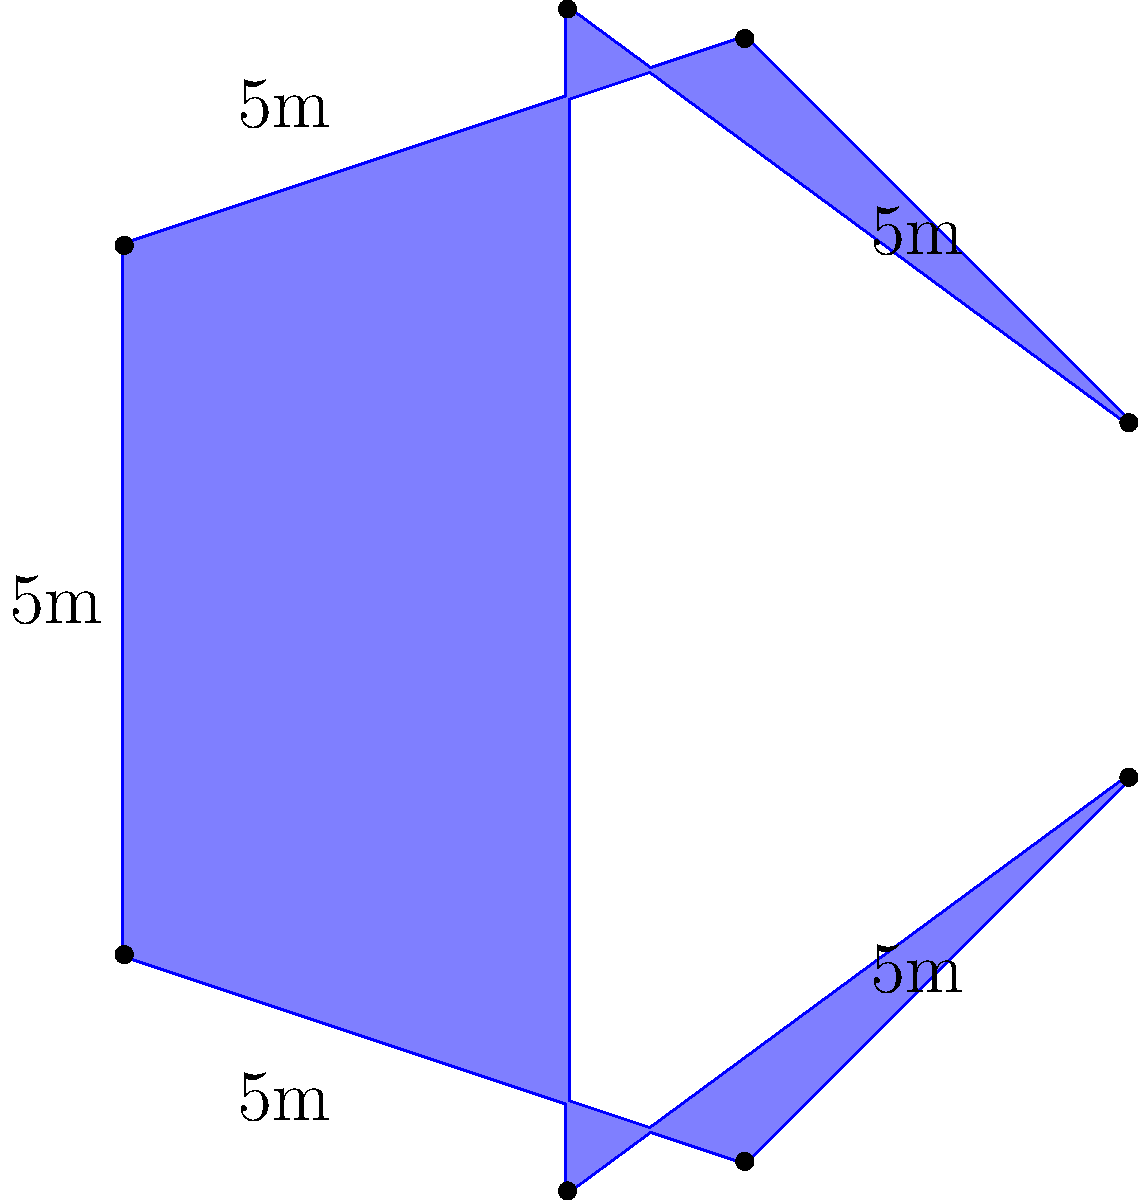Our interfaith community is planning to create a star-shaped meditation space. The space will have 8 points, with each side measuring 5 meters. What is the perimeter of this meditation space, and how might this shape symbolize unity in our diverse community outreach programs? To calculate the perimeter of the star-shaped meditation space, we need to follow these steps:

1. Identify the number of sides: The star has 8 points, which means it has 8 sides.

2. Determine the length of each side: Each side is given as 5 meters.

3. Calculate the perimeter: The perimeter is the sum of all side lengths.
   Perimeter = Number of sides × Length of each side
   Perimeter = 8 × 5 meters = 40 meters

Symbolism in community outreach:
The star shape can symbolize unity and inclusivity in several ways:

1. Eight-pointed star: In various cultures and religions, the number 8 represents completeness and new beginnings.

2. Equal sides: The equal length of all sides represents equality among different faith traditions.

3. Inward and outward points: These can symbolize both introspection and outreach, reflecting the dual nature of prayer and community service.

4. Central space: The area within the star can represent a common ground where all faiths meet.

5. Interconnectedness: The continuous path around the star symbolizes the interconnectedness of all community members and faith traditions.

This shape can serve as a powerful visual reminder of our community's commitment to interfaith cooperation and inclusive outreach programs.
Answer: 40 meters 